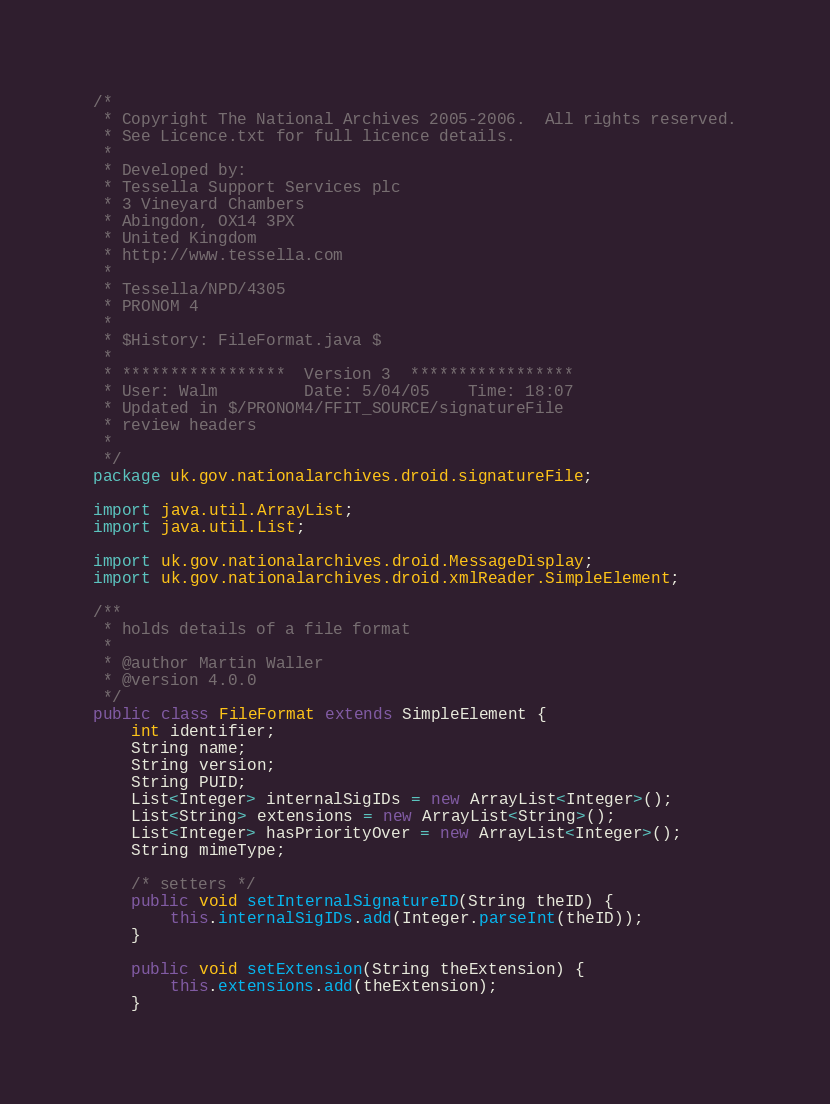<code> <loc_0><loc_0><loc_500><loc_500><_Java_>/*
 * Copyright The National Archives 2005-2006.  All rights reserved.
 * See Licence.txt for full licence details.
 *
 * Developed by:
 * Tessella Support Services plc
 * 3 Vineyard Chambers
 * Abingdon, OX14 3PX
 * United Kingdom
 * http://www.tessella.com
 *
 * Tessella/NPD/4305
 * PRONOM 4
 *
 * $History: FileFormat.java $
 * 
 * *****************  Version 3  *****************
 * User: Walm         Date: 5/04/05    Time: 18:07
 * Updated in $/PRONOM4/FFIT_SOURCE/signatureFile
 * review headers
 *
 */
package uk.gov.nationalarchives.droid.signatureFile;

import java.util.ArrayList;
import java.util.List;

import uk.gov.nationalarchives.droid.MessageDisplay;
import uk.gov.nationalarchives.droid.xmlReader.SimpleElement;

/**
 * holds details of a file format
 *
 * @author Martin Waller
 * @version 4.0.0
 */
public class FileFormat extends SimpleElement {
    int identifier;
    String name;
    String version;
    String PUID;
    List<Integer> internalSigIDs = new ArrayList<Integer>();
    List<String> extensions = new ArrayList<String>();
    List<Integer> hasPriorityOver = new ArrayList<Integer>();
    String mimeType;

    /* setters */
    public void setInternalSignatureID(String theID) {
        this.internalSigIDs.add(Integer.parseInt(theID));
    }

    public void setExtension(String theExtension) {
        this.extensions.add(theExtension);
    }
</code> 